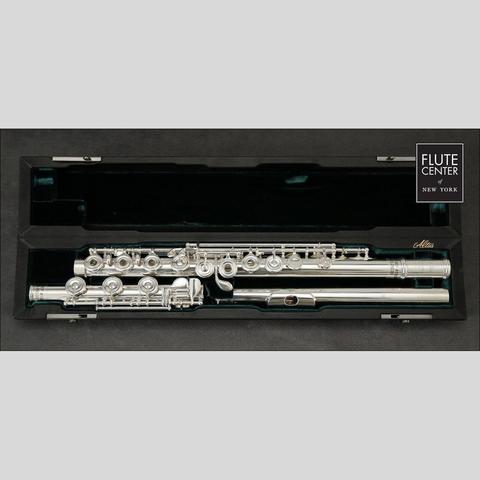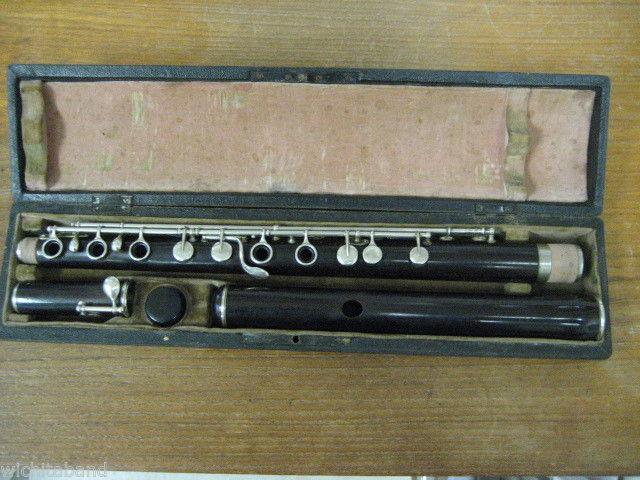The first image is the image on the left, the second image is the image on the right. Evaluate the accuracy of this statement regarding the images: "One of the flutes is blue.". Is it true? Answer yes or no. No. The first image is the image on the left, the second image is the image on the right. Examine the images to the left and right. Is the description "One image shows a disassembled instrument in an open case displayed horizontally, and the other image shows items that are not in a case." accurate? Answer yes or no. No. 